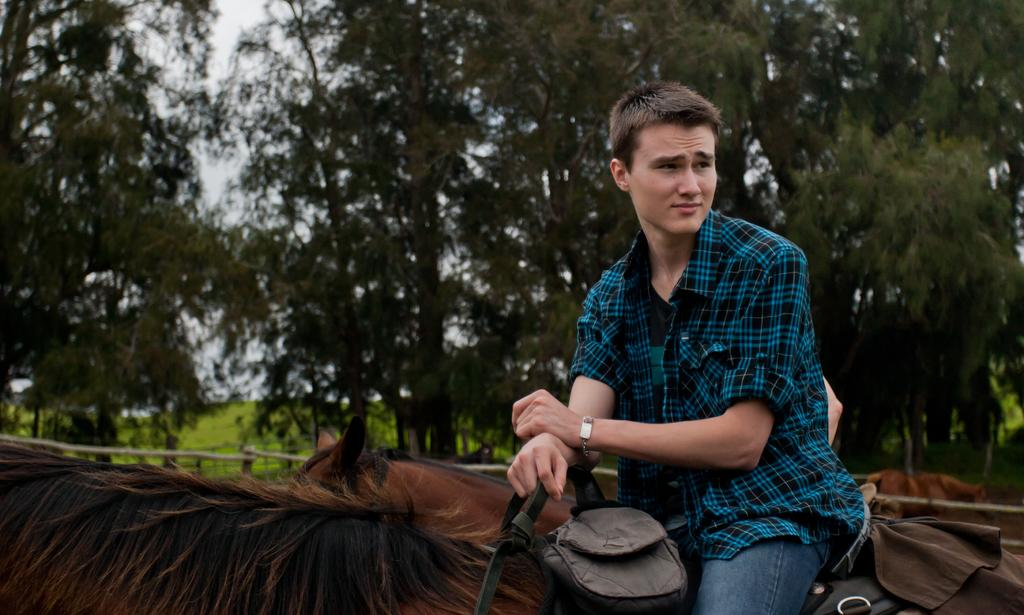What is the main subject of the image? The main subject of the image is a boy. What is the boy doing in the image? The boy is riding a horse in the image. What is the boy wearing in the image? The boy is wearing a blue checkered shirt and denim pants in the image. What can be seen in the background of the image? There are trees in the background of the image. What type of joke is the boy telling to the quilt in the image? There is no quilt or joke present in the image; the boy is riding a horse. What kind of pet is accompanying the boy in the image? There is no pet present in the image; the boy is riding a horse. 